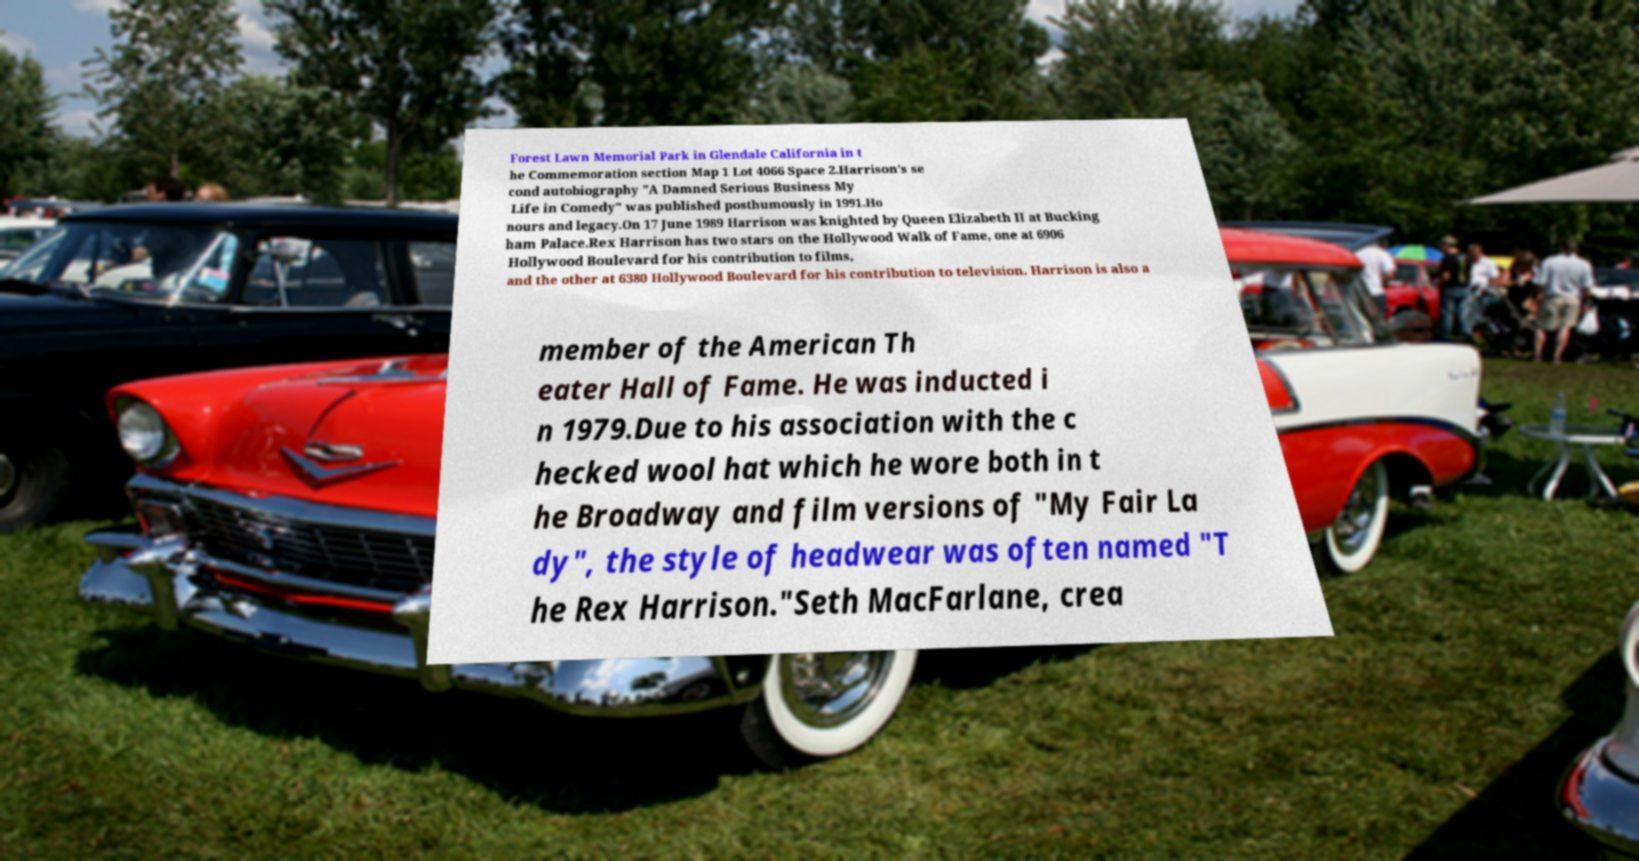Could you assist in decoding the text presented in this image and type it out clearly? Forest Lawn Memorial Park in Glendale California in t he Commemoration section Map 1 Lot 4066 Space 2.Harrison's se cond autobiography "A Damned Serious Business My Life in Comedy" was published posthumously in 1991.Ho nours and legacy.On 17 June 1989 Harrison was knighted by Queen Elizabeth II at Bucking ham Palace.Rex Harrison has two stars on the Hollywood Walk of Fame, one at 6906 Hollywood Boulevard for his contribution to films, and the other at 6380 Hollywood Boulevard for his contribution to television. Harrison is also a member of the American Th eater Hall of Fame. He was inducted i n 1979.Due to his association with the c hecked wool hat which he wore both in t he Broadway and film versions of "My Fair La dy", the style of headwear was often named "T he Rex Harrison."Seth MacFarlane, crea 